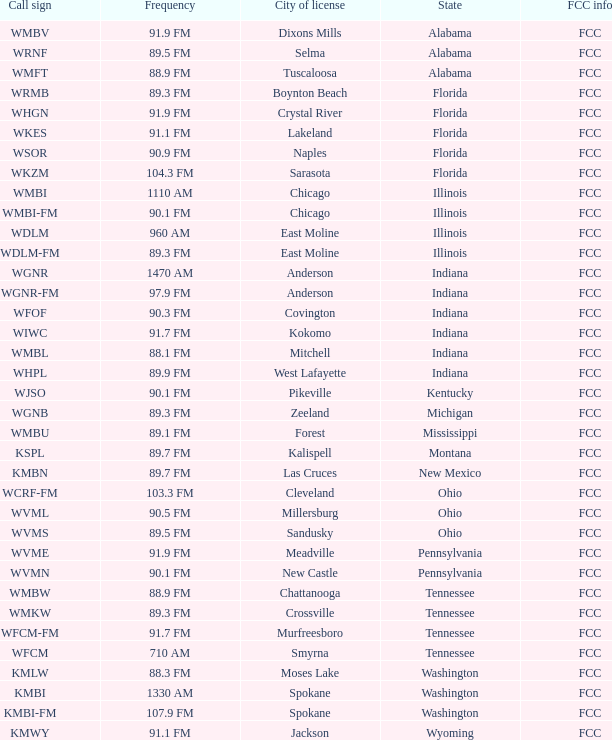What is the frequency of the radio station with a call sign of WGNR-FM? 97.9 FM. 